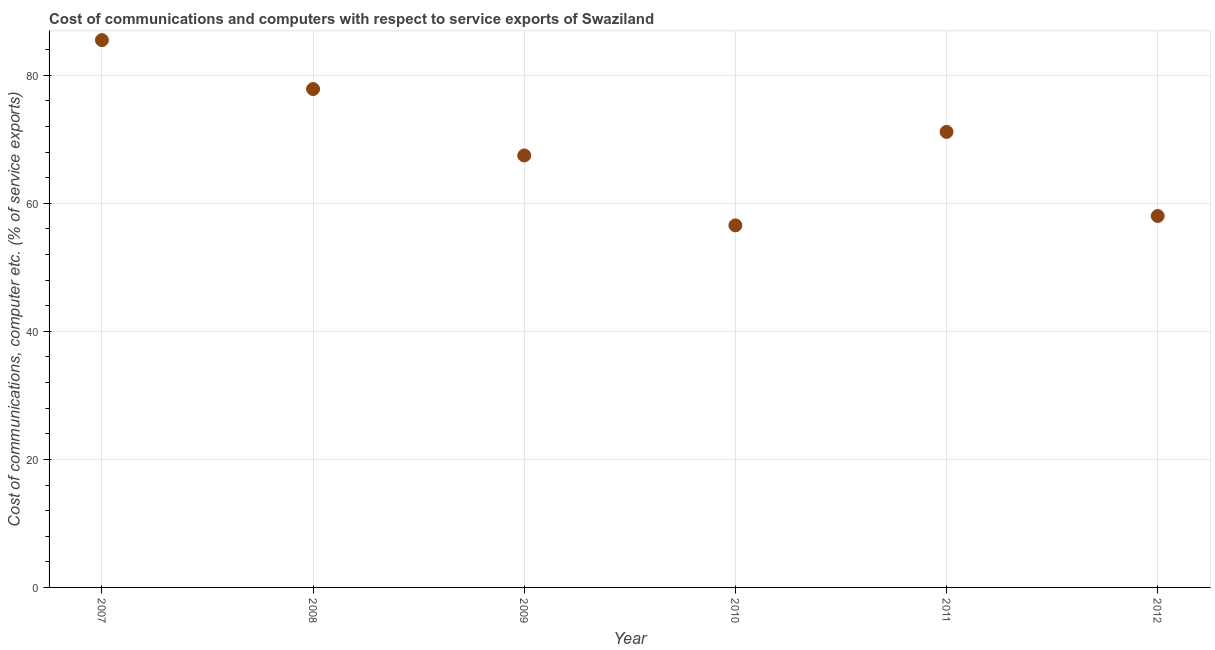What is the cost of communications and computer in 2008?
Your answer should be very brief. 77.86. Across all years, what is the maximum cost of communications and computer?
Ensure brevity in your answer.  85.51. Across all years, what is the minimum cost of communications and computer?
Your answer should be compact. 56.56. In which year was the cost of communications and computer maximum?
Offer a very short reply. 2007. What is the sum of the cost of communications and computer?
Your answer should be very brief. 416.61. What is the difference between the cost of communications and computer in 2007 and 2011?
Your response must be concise. 14.34. What is the average cost of communications and computer per year?
Offer a terse response. 69.43. What is the median cost of communications and computer?
Give a very brief answer. 69.32. What is the ratio of the cost of communications and computer in 2007 to that in 2012?
Offer a terse response. 1.47. Is the cost of communications and computer in 2008 less than that in 2010?
Your answer should be very brief. No. Is the difference between the cost of communications and computer in 2009 and 2011 greater than the difference between any two years?
Your answer should be compact. No. What is the difference between the highest and the second highest cost of communications and computer?
Ensure brevity in your answer.  7.65. Is the sum of the cost of communications and computer in 2009 and 2010 greater than the maximum cost of communications and computer across all years?
Your answer should be compact. Yes. What is the difference between the highest and the lowest cost of communications and computer?
Offer a terse response. 28.94. In how many years, is the cost of communications and computer greater than the average cost of communications and computer taken over all years?
Make the answer very short. 3. How many dotlines are there?
Your answer should be very brief. 1. How many years are there in the graph?
Make the answer very short. 6. What is the difference between two consecutive major ticks on the Y-axis?
Make the answer very short. 20. What is the title of the graph?
Ensure brevity in your answer.  Cost of communications and computers with respect to service exports of Swaziland. What is the label or title of the X-axis?
Offer a very short reply. Year. What is the label or title of the Y-axis?
Your response must be concise. Cost of communications, computer etc. (% of service exports). What is the Cost of communications, computer etc. (% of service exports) in 2007?
Your answer should be compact. 85.51. What is the Cost of communications, computer etc. (% of service exports) in 2008?
Provide a succinct answer. 77.86. What is the Cost of communications, computer etc. (% of service exports) in 2009?
Your response must be concise. 67.48. What is the Cost of communications, computer etc. (% of service exports) in 2010?
Keep it short and to the point. 56.56. What is the Cost of communications, computer etc. (% of service exports) in 2011?
Ensure brevity in your answer.  71.17. What is the Cost of communications, computer etc. (% of service exports) in 2012?
Offer a terse response. 58.03. What is the difference between the Cost of communications, computer etc. (% of service exports) in 2007 and 2008?
Give a very brief answer. 7.65. What is the difference between the Cost of communications, computer etc. (% of service exports) in 2007 and 2009?
Ensure brevity in your answer.  18.03. What is the difference between the Cost of communications, computer etc. (% of service exports) in 2007 and 2010?
Your answer should be compact. 28.94. What is the difference between the Cost of communications, computer etc. (% of service exports) in 2007 and 2011?
Offer a very short reply. 14.34. What is the difference between the Cost of communications, computer etc. (% of service exports) in 2007 and 2012?
Provide a succinct answer. 27.48. What is the difference between the Cost of communications, computer etc. (% of service exports) in 2008 and 2009?
Keep it short and to the point. 10.38. What is the difference between the Cost of communications, computer etc. (% of service exports) in 2008 and 2010?
Give a very brief answer. 21.3. What is the difference between the Cost of communications, computer etc. (% of service exports) in 2008 and 2011?
Give a very brief answer. 6.69. What is the difference between the Cost of communications, computer etc. (% of service exports) in 2008 and 2012?
Your response must be concise. 19.83. What is the difference between the Cost of communications, computer etc. (% of service exports) in 2009 and 2010?
Keep it short and to the point. 10.92. What is the difference between the Cost of communications, computer etc. (% of service exports) in 2009 and 2011?
Offer a terse response. -3.68. What is the difference between the Cost of communications, computer etc. (% of service exports) in 2009 and 2012?
Provide a short and direct response. 9.46. What is the difference between the Cost of communications, computer etc. (% of service exports) in 2010 and 2011?
Provide a succinct answer. -14.6. What is the difference between the Cost of communications, computer etc. (% of service exports) in 2010 and 2012?
Your answer should be compact. -1.46. What is the difference between the Cost of communications, computer etc. (% of service exports) in 2011 and 2012?
Make the answer very short. 13.14. What is the ratio of the Cost of communications, computer etc. (% of service exports) in 2007 to that in 2008?
Keep it short and to the point. 1.1. What is the ratio of the Cost of communications, computer etc. (% of service exports) in 2007 to that in 2009?
Offer a terse response. 1.27. What is the ratio of the Cost of communications, computer etc. (% of service exports) in 2007 to that in 2010?
Keep it short and to the point. 1.51. What is the ratio of the Cost of communications, computer etc. (% of service exports) in 2007 to that in 2011?
Your answer should be compact. 1.2. What is the ratio of the Cost of communications, computer etc. (% of service exports) in 2007 to that in 2012?
Ensure brevity in your answer.  1.47. What is the ratio of the Cost of communications, computer etc. (% of service exports) in 2008 to that in 2009?
Keep it short and to the point. 1.15. What is the ratio of the Cost of communications, computer etc. (% of service exports) in 2008 to that in 2010?
Offer a terse response. 1.38. What is the ratio of the Cost of communications, computer etc. (% of service exports) in 2008 to that in 2011?
Your response must be concise. 1.09. What is the ratio of the Cost of communications, computer etc. (% of service exports) in 2008 to that in 2012?
Ensure brevity in your answer.  1.34. What is the ratio of the Cost of communications, computer etc. (% of service exports) in 2009 to that in 2010?
Offer a very short reply. 1.19. What is the ratio of the Cost of communications, computer etc. (% of service exports) in 2009 to that in 2011?
Ensure brevity in your answer.  0.95. What is the ratio of the Cost of communications, computer etc. (% of service exports) in 2009 to that in 2012?
Your response must be concise. 1.16. What is the ratio of the Cost of communications, computer etc. (% of service exports) in 2010 to that in 2011?
Provide a succinct answer. 0.8. What is the ratio of the Cost of communications, computer etc. (% of service exports) in 2011 to that in 2012?
Your answer should be compact. 1.23. 